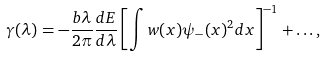<formula> <loc_0><loc_0><loc_500><loc_500>\gamma ( \lambda ) = - \frac { b \lambda } { 2 \pi } \frac { d E } { d \lambda } \left [ \int w ( x ) \psi _ { - } ( x ) ^ { 2 } d x \right ] ^ { - 1 } + \dots ,</formula> 